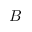<formula> <loc_0><loc_0><loc_500><loc_500>B</formula> 